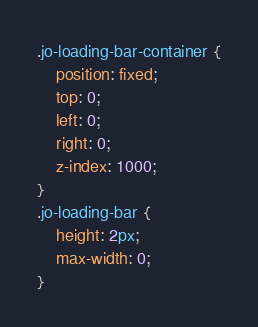<code> <loc_0><loc_0><loc_500><loc_500><_CSS_>.jo-loading-bar-container {
    position: fixed;
    top: 0;
    left: 0;
    right: 0;
    z-index: 1000;
}
.jo-loading-bar {
    height: 2px;
    max-width: 0;
}

</code> 